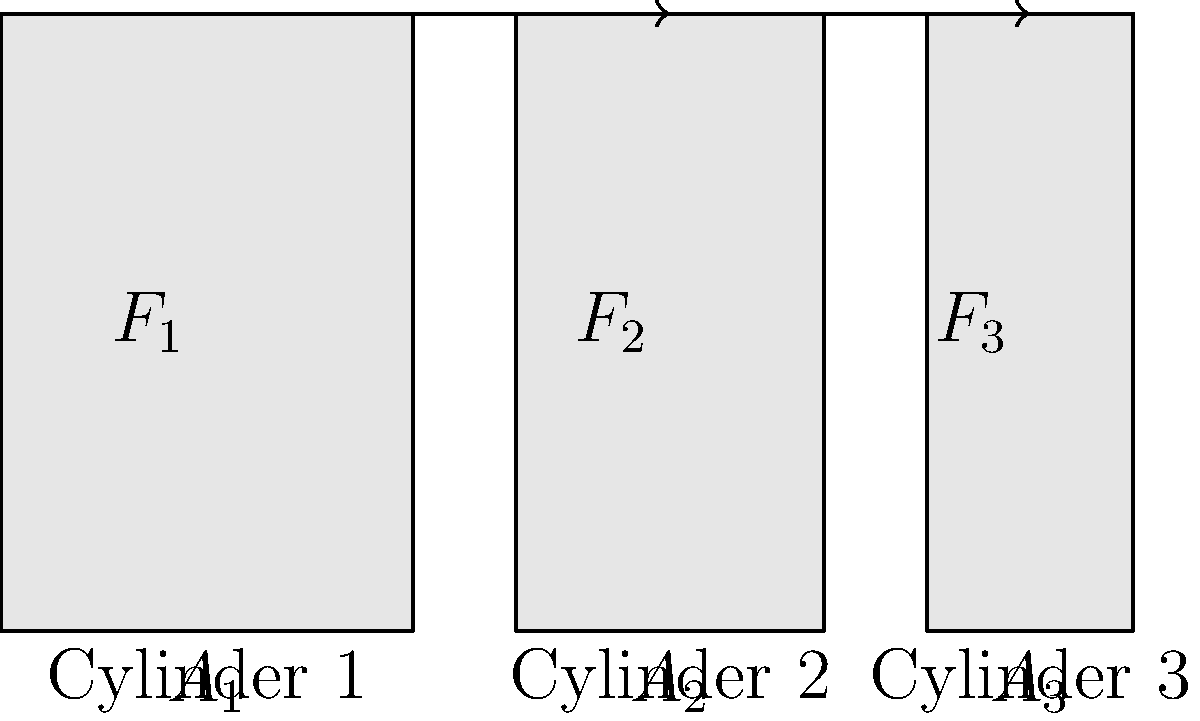As a handyman, you're working on a hydraulic system with three connected cylinders of different diameters. The system is in equilibrium, and you need to determine the pressure. If the force applied to Cylinder 1 is 1000 N and its area is 100 cm², what is the force applied to Cylinder 3 if its area is 25 cm²? Let's approach this step-by-step:

1) In a hydraulic system, the pressure is constant throughout the system when it's in equilibrium. This is based on Pascal's principle.

2) We can calculate the pressure in the system using the information from Cylinder 1:

   $P = \frac{F_1}{A_1} = \frac{1000 \text{ N}}{100 \text{ cm}^2} = 10 \text{ N}/\text{cm}^2$

3) Since the pressure is the same in all cylinders, we can use this to find the force on Cylinder 3:

   $P = \frac{F_3}{A_3}$

4) Rearranging the equation to solve for $F_3$:

   $F_3 = P \times A_3$

5) Substituting the known values:

   $F_3 = 10 \text{ N}/\text{cm}^2 \times 25 \text{ cm}^2 = 250 \text{ N}$

Therefore, the force applied to Cylinder 3 is 250 N.
Answer: 250 N 